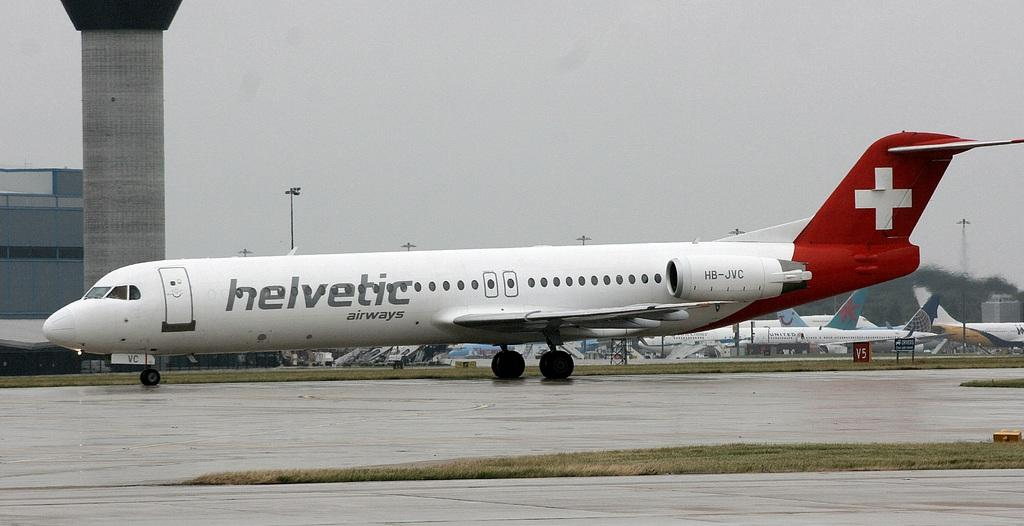<image>
Relay a brief, clear account of the picture shown. An Helvetic Airways plane coats along a landing strip. 